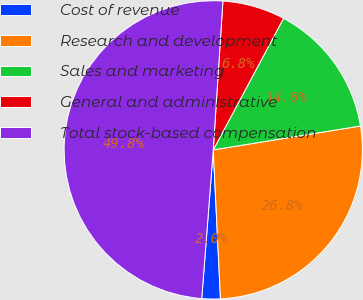<chart> <loc_0><loc_0><loc_500><loc_500><pie_chart><fcel>Cost of revenue<fcel>Research and development<fcel>Sales and marketing<fcel>General and administrative<fcel>Total stock-based compensation<nl><fcel>2.0%<fcel>26.79%<fcel>14.63%<fcel>6.78%<fcel>49.8%<nl></chart> 